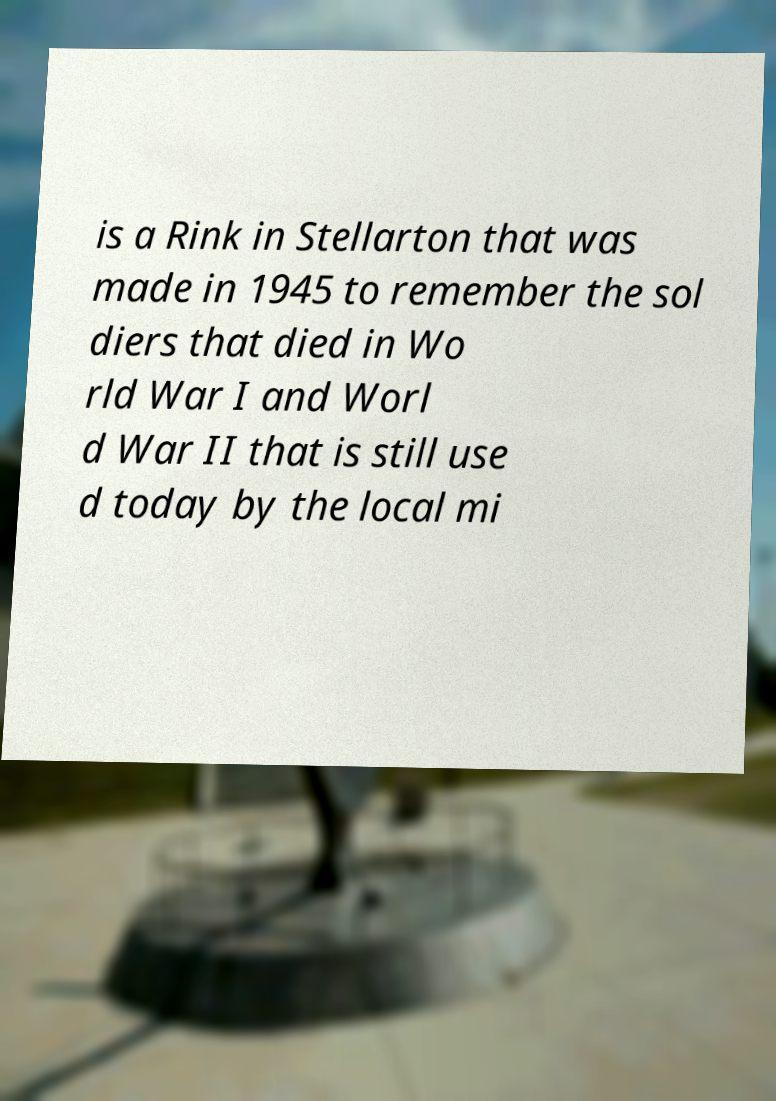Could you assist in decoding the text presented in this image and type it out clearly? is a Rink in Stellarton that was made in 1945 to remember the sol diers that died in Wo rld War I and Worl d War II that is still use d today by the local mi 